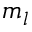Convert formula to latex. <formula><loc_0><loc_0><loc_500><loc_500>m _ { l }</formula> 